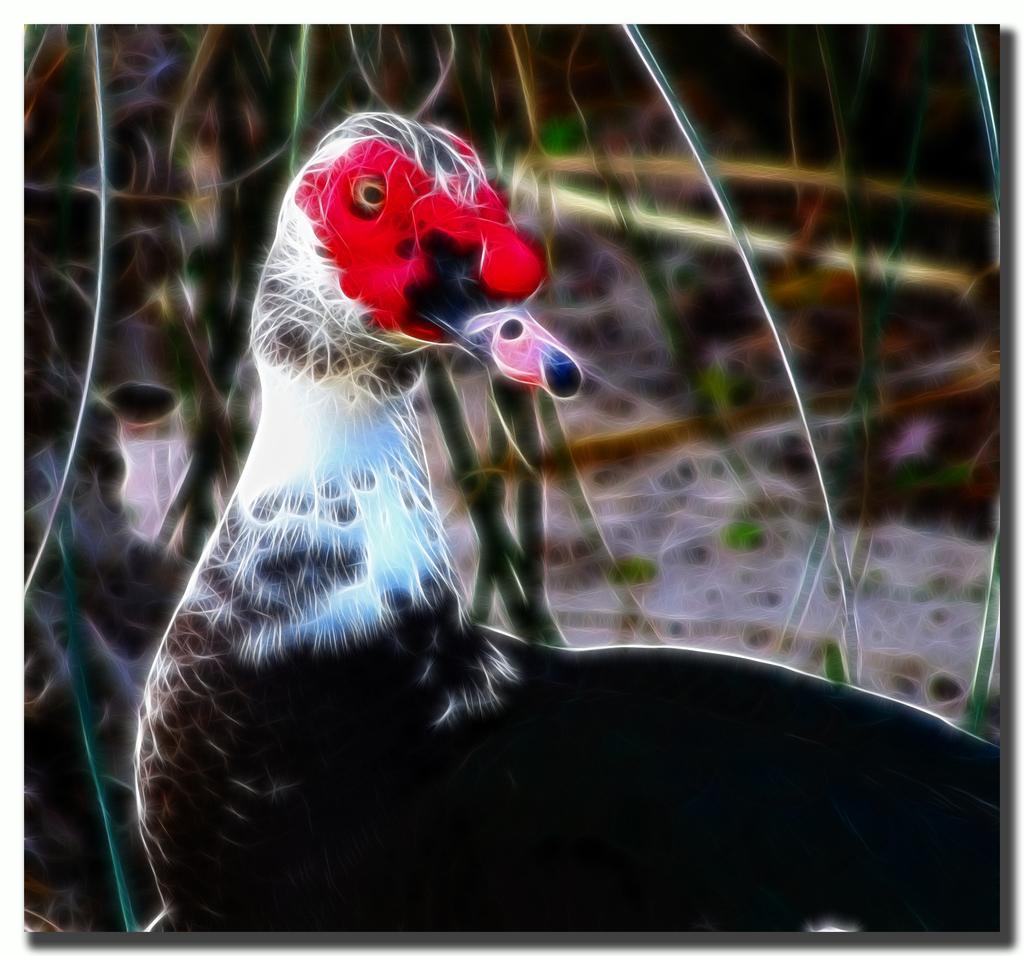Describe this image in one or two sentences. In this image I can see an edited image of the bird which is in white, blue, black and red color. In the background I can see the plants. 